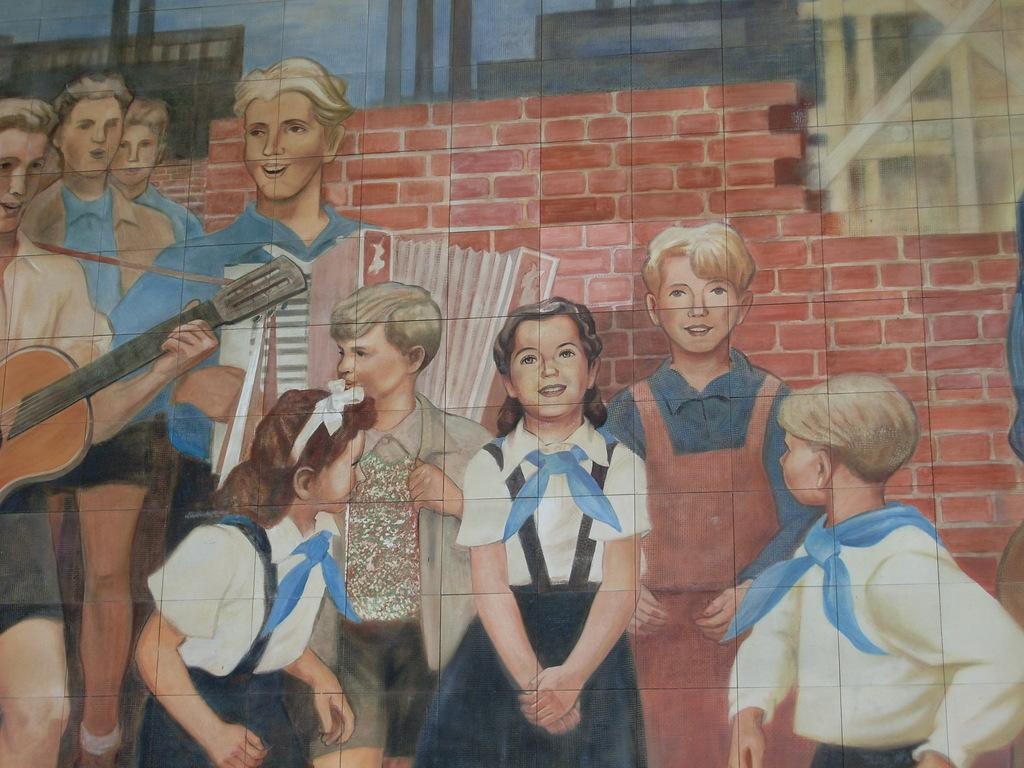What is present on the wall in the image? There is art on the wall in the image. What does the art on the wall depict? The art depicts a few people. Can you describe the art on the wall? The art on the wall features a few people, but we cannot determine the specific details or style from the provided facts. What type of belief is represented by the dime on the wall in the image? There is no dime present in the image, and therefore no belief can be associated with it. 